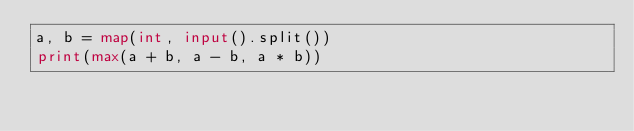Convert code to text. <code><loc_0><loc_0><loc_500><loc_500><_Python_>a, b = map(int, input().split())
print(max(a + b, a - b, a * b))</code> 